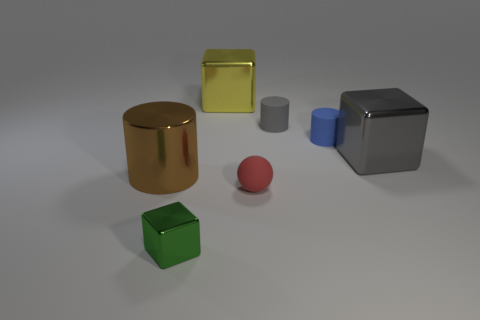Subtract all small matte cylinders. How many cylinders are left? 1 Add 1 big green matte things. How many objects exist? 8 Subtract all blocks. How many objects are left? 4 Subtract all small shiny cubes. Subtract all spheres. How many objects are left? 5 Add 5 metal blocks. How many metal blocks are left? 8 Add 5 small gray matte spheres. How many small gray matte spheres exist? 5 Subtract 1 yellow blocks. How many objects are left? 6 